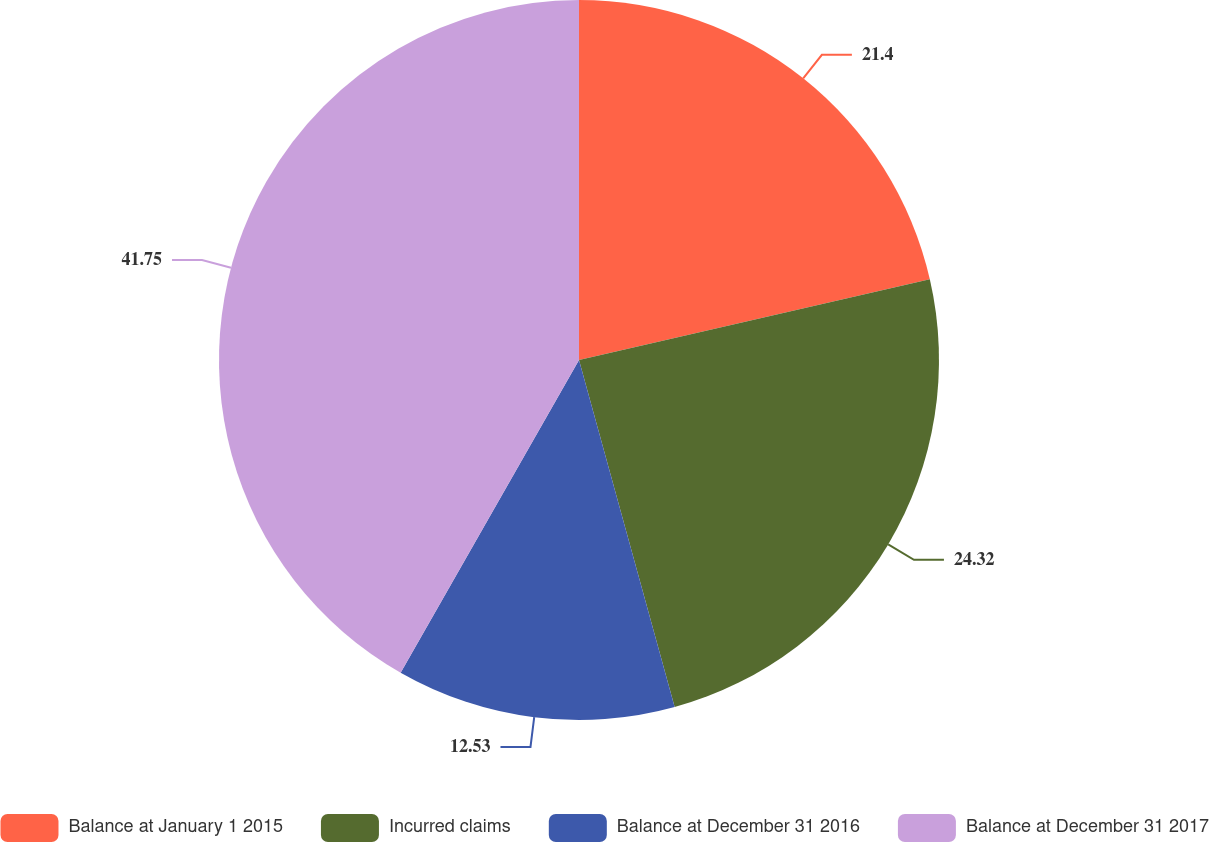Convert chart to OTSL. <chart><loc_0><loc_0><loc_500><loc_500><pie_chart><fcel>Balance at January 1 2015<fcel>Incurred claims<fcel>Balance at December 31 2016<fcel>Balance at December 31 2017<nl><fcel>21.4%<fcel>24.32%<fcel>12.53%<fcel>41.75%<nl></chart> 